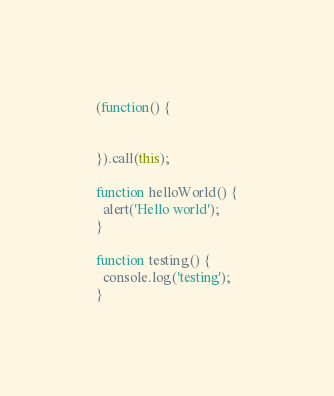Convert code to text. <code><loc_0><loc_0><loc_500><loc_500><_JavaScript_>(function() {


}).call(this);

function helloWorld() {
  alert('Hello world');
}

function testing() {
  console.log('testing');
}

</code> 